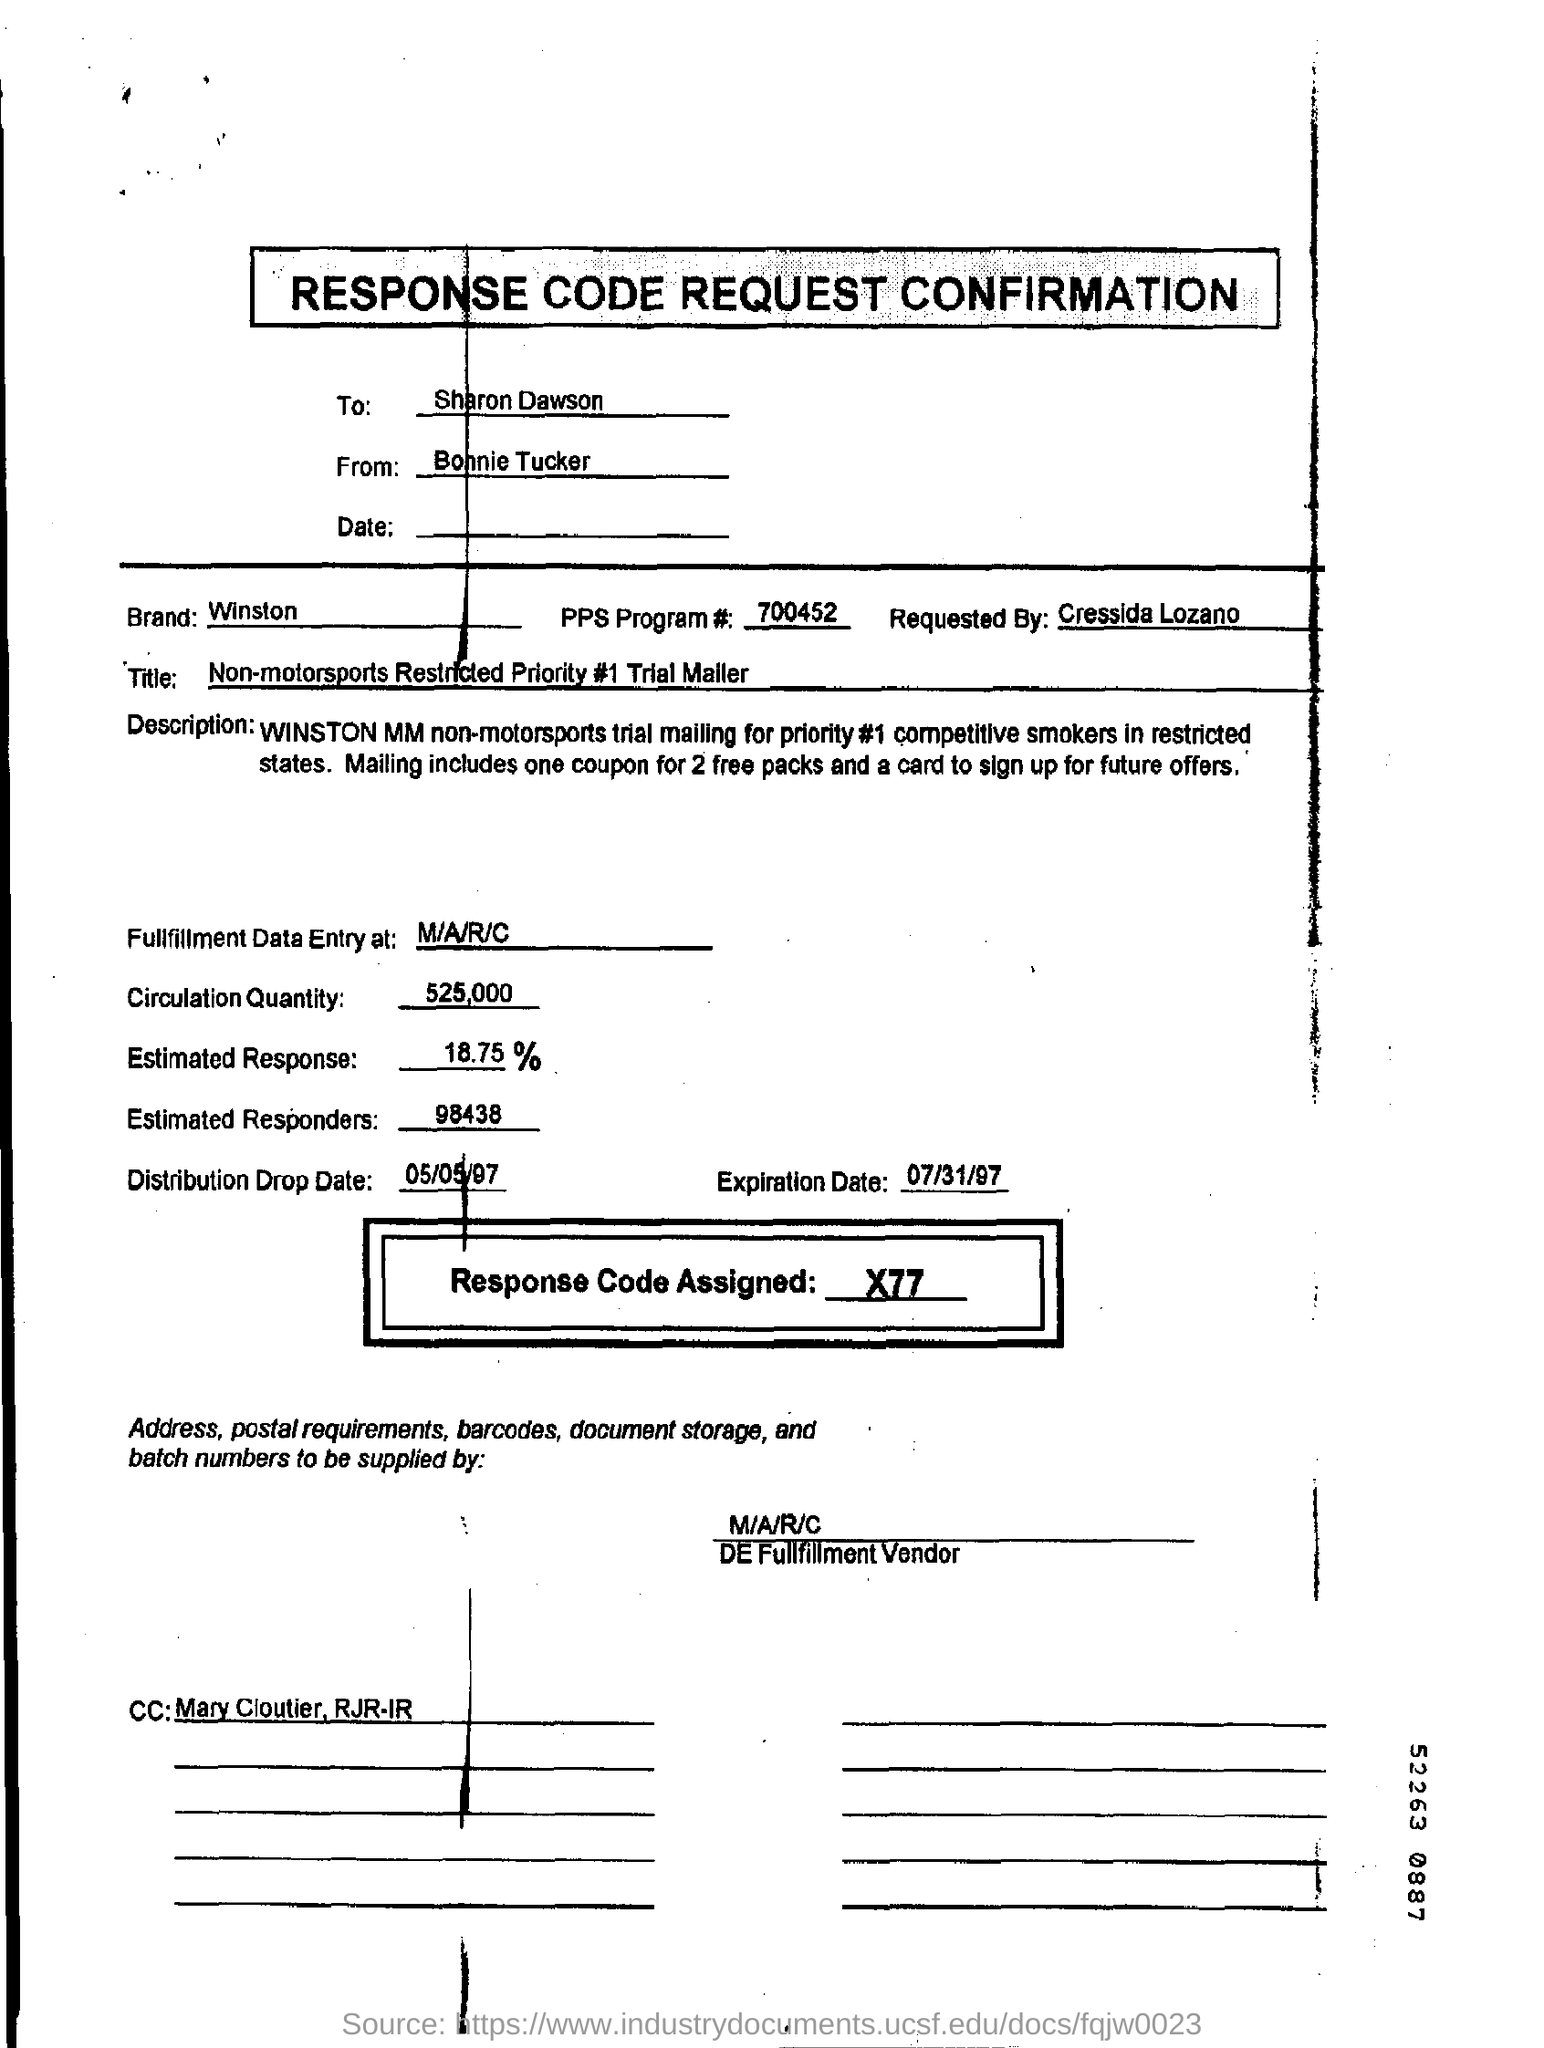Draw attention to some important aspects in this diagram. The distribution drop date is May 5th, 1997. To whom is this document addressed? Sharon Dawson is the recipient. 